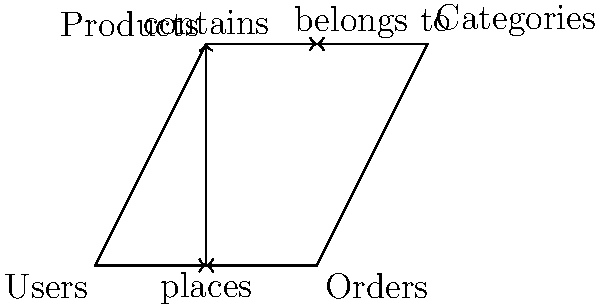In the given entity-relationship diagram representing a database schema for an e-commerce application, what is the maximum number of many-to-many relationships that can exist between the four entities (Users, Orders, Products, and Categories)? To determine the maximum number of many-to-many relationships, we need to analyze the possible relationships between each pair of entities:

1. Users and Orders: This is likely a one-to-many relationship (one user can place many orders), not many-to-many.

2. Users and Products: This could be a many-to-many relationship (users can purchase multiple products, and products can be purchased by multiple users).

3. Users and Categories: This is unlikely to be a direct many-to-many relationship in most e-commerce systems.

4. Orders and Products: This is typically a many-to-many relationship (one order can contain multiple products, and one product can be in multiple orders).

5. Orders and Categories: This is unlikely to be a direct many-to-many relationship.

6. Products and Categories: This could be a many-to-many relationship (one product can belong to multiple categories, and one category can contain multiple products).

From this analysis, we can identify a maximum of three potential many-to-many relationships:
1. Users and Products
2. Orders and Products
3. Products and Categories

Therefore, the maximum number of many-to-many relationships in this schema is 3.
Answer: 3 